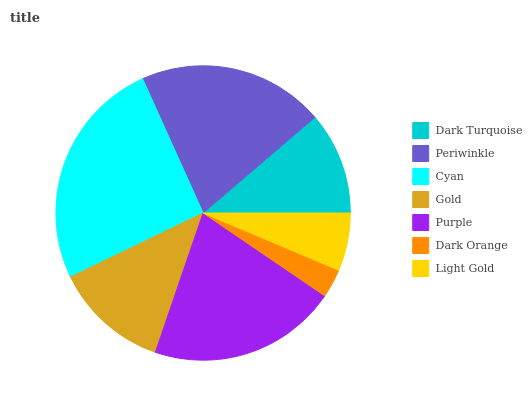Is Dark Orange the minimum?
Answer yes or no. Yes. Is Cyan the maximum?
Answer yes or no. Yes. Is Periwinkle the minimum?
Answer yes or no. No. Is Periwinkle the maximum?
Answer yes or no. No. Is Periwinkle greater than Dark Turquoise?
Answer yes or no. Yes. Is Dark Turquoise less than Periwinkle?
Answer yes or no. Yes. Is Dark Turquoise greater than Periwinkle?
Answer yes or no. No. Is Periwinkle less than Dark Turquoise?
Answer yes or no. No. Is Gold the high median?
Answer yes or no. Yes. Is Gold the low median?
Answer yes or no. Yes. Is Cyan the high median?
Answer yes or no. No. Is Dark Turquoise the low median?
Answer yes or no. No. 